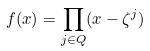Convert formula to latex. <formula><loc_0><loc_0><loc_500><loc_500>f ( x ) = \prod _ { j \in Q } ( x - \zeta ^ { j } )</formula> 